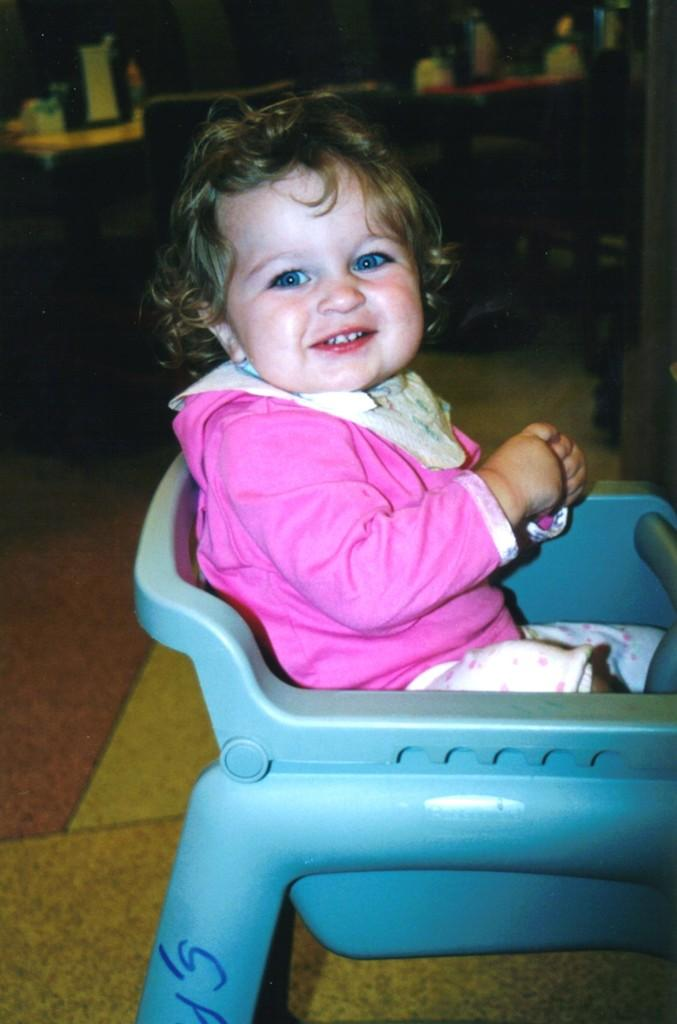What is the main subject of the image? There is a baby in the image. What is the baby doing in the image? The baby is sitting in a chair. What is the baby wearing in the image? The baby is wearing a pink shirt. What can be seen in the background of the image? There is a table and chairs in the background of the image. What type of wax is being used to polish the baby's throne in the image? There is no throne or wax present in the image; it features a baby sitting in a chair. What type of brush is being used to clean the baby's hair in the image? There is no brush or hair cleaning activity depicted in the image; the baby is simply sitting in a chair wearing a pink shirt. 